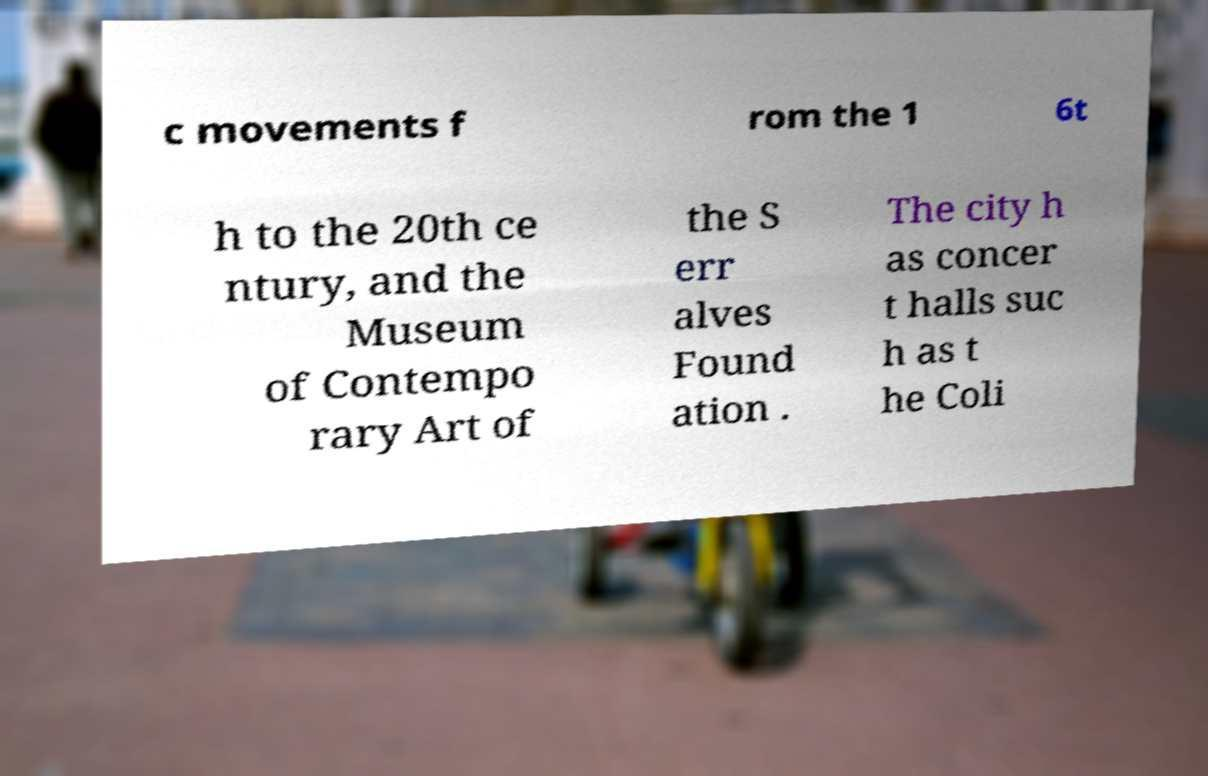Can you accurately transcribe the text from the provided image for me? c movements f rom the 1 6t h to the 20th ce ntury, and the Museum of Contempo rary Art of the S err alves Found ation . The city h as concer t halls suc h as t he Coli 